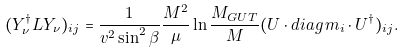<formula> <loc_0><loc_0><loc_500><loc_500>( Y _ { \nu } ^ { \dagger } L Y _ { \nu } ) _ { i j } = \frac { 1 } { v ^ { 2 } \sin ^ { 2 } \beta } \frac { M ^ { 2 } } { \mu } \ln \frac { M _ { G U T } } { M } ( U \cdot d i a g \, m _ { i } \cdot U ^ { \dagger } ) _ { i j } .</formula> 